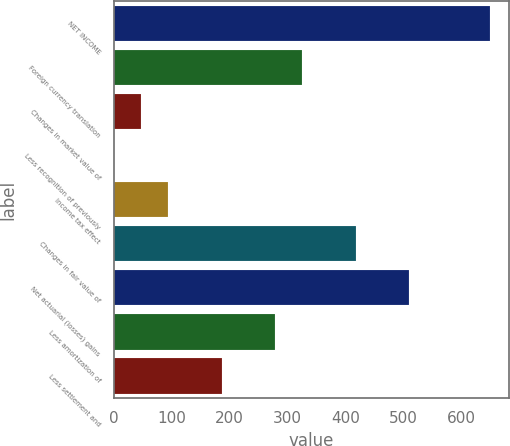Convert chart. <chart><loc_0><loc_0><loc_500><loc_500><bar_chart><fcel>NET INCOME<fcel>Foreign currency translation<fcel>Changes in market value of<fcel>Less recognition of previously<fcel>Income tax effect<fcel>Changes in fair value of<fcel>Net actuarial (losses) gains<fcel>Less amortization of<fcel>Less settlement and<nl><fcel>650.32<fcel>325.31<fcel>46.73<fcel>0.3<fcel>93.16<fcel>418.17<fcel>511.03<fcel>278.88<fcel>186.02<nl></chart> 